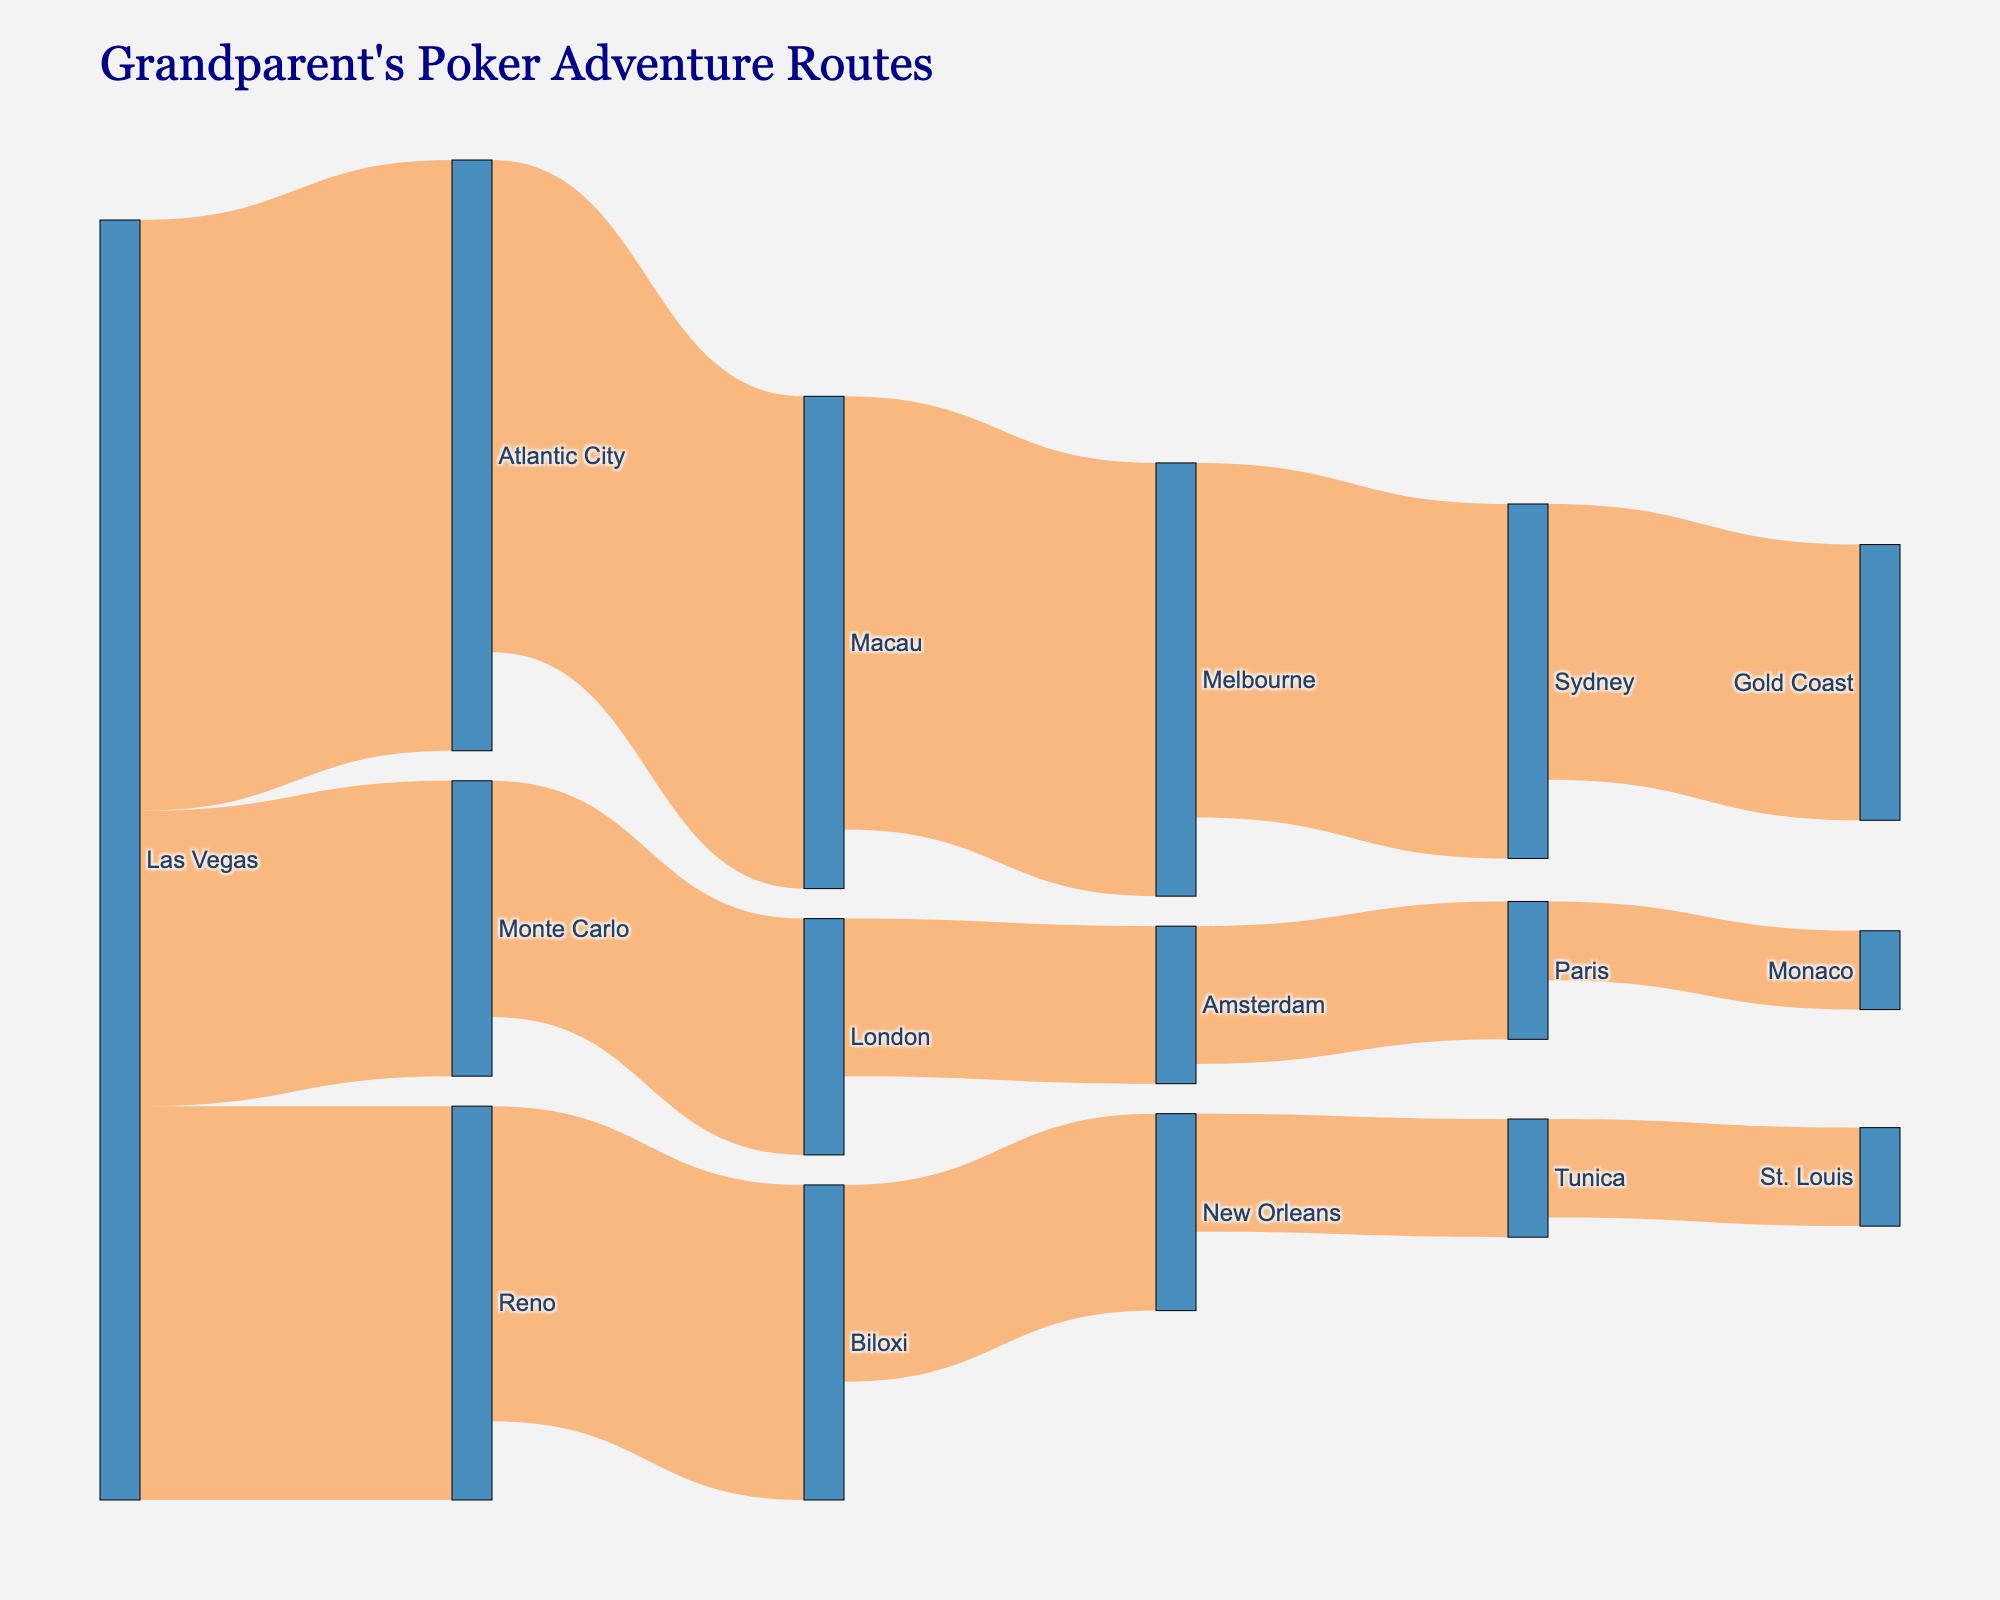what is the title of the plot? The title of the plot is located at the top of the diagram. It describes what the plot is about.
Answer: Grandparent's Poker Adventure Routes Which location connects to both Monte Carlo and Atlantic City? By following the lines from the nodes, you can see which one branches out to both Monte Carlo and Atlantic City.
Answer: Las Vegas What is the total value of routes originating from Las Vegas? Sum the values of all the routes that start from Las Vegas (Las Vegas -> Atlantic City, Las Vegas -> Reno, Las Vegas -> Monte Carlo). 150 + 100 + 75 = 325
Answer: 325 Is the route value from London to Paris higher than the route value from Paris to Monaco? Compare the numerical values associated with the routes from London to Paris and from Paris to Monaco. 40 > 20
Answer: Yes How many locations have connections leading to them from exactly one other location? Count the number of target locations that have exactly one incoming line from another node.
Answer: 9 Which target location has the highest value for a single route connected to it? Find the target with the maximum value from its incoming route. By looking at the values, check the route with the maximum value leading to a target.
Answer: Macau (value 125) Which locations have direct routes that connect to New Orleans? Look for routes where New Orleans is the target, then identify the source of these routes.
Answer: Biloxi What is the overall number of unique locations shown in the diagram? Count all distinct nodes that appear either as a source or a target in the dataset.
Answer: 15 How does the value of the route from Melbourne to Sydney compare to the total value of routes from Monte Carlo? Compare the value of the Melbourne to Sydney route (90) to the sum of the values of all routes originating from Monte Carlo (60). 90 > 60
Answer: Higher If you sum all the values of routes ending in London, what would be the result? Add the values of all routes where London is the target: only one route ends in London (Monte Carlo -> London) with value 60.
Answer: 60 